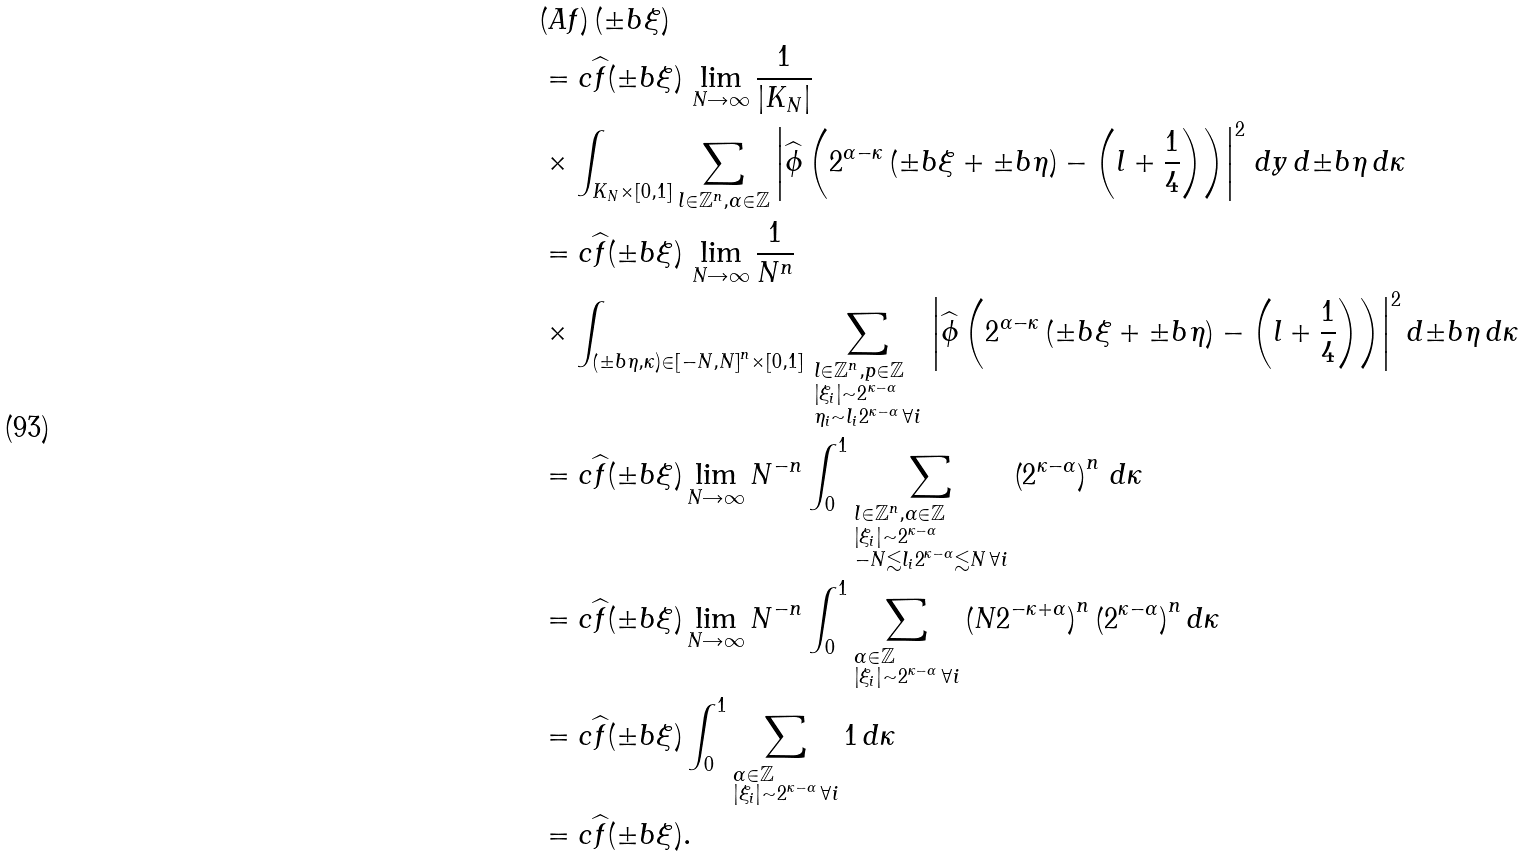Convert formula to latex. <formula><loc_0><loc_0><loc_500><loc_500>& ( A f ) \, ( { \pm b { \xi } } ) \\ & = c \widehat { f } ( { \pm b { \xi } } ) \, \lim _ { N \rightarrow \infty } \frac { 1 } { | K _ { N } | } \\ & \times \int _ { K _ { N } \times \left [ 0 , 1 \right ] } \sum _ { { l } \in \mathbb { Z } ^ { n } , \alpha \in \mathbb { Z } } \left | { \widehat { \phi } } \left ( 2 ^ { \alpha - \kappa } \left ( { \pm b { \xi } } + { \pm b { \eta } } \right ) - \left ( { l } + \frac { 1 } { 4 } \right ) \right ) \right | ^ { 2 } \, d { y } \, d { \pm b { \eta } } \, d \kappa \\ & = c \widehat { f } ( { \pm b { \xi } } ) \, \lim _ { N \rightarrow \infty } \frac { 1 } { N ^ { n } } \\ & \times \int _ { \left ( { \pm b { \eta } } , \kappa \right ) \in \left [ - N , N \right ] ^ { n } \times \left [ 0 , 1 \right ] } \, \sum _ { \begin{subarray} { c } { l } \in \mathbb { Z } ^ { n } , p \in \mathbb { Z } \\ \left | \xi _ { i } \right | \sim 2 ^ { \kappa - \alpha } \\ \eta _ { i } \sim l _ { i } 2 ^ { \kappa - \alpha } \, \forall i \end{subarray} } \, \left | { \widehat { \phi } } \left ( 2 ^ { \alpha - \kappa } \left ( { \pm b { \xi } } + { \pm b { \eta } } \right ) - \left ( { l } + \frac { 1 } { 4 } \right ) \right ) \right | ^ { 2 } d { \pm b { \eta } } \, d \kappa \\ & = c \widehat { f } ( { \pm b { \xi } } ) \lim _ { N \rightarrow \infty } N ^ { - n } \int _ { 0 } ^ { 1 } \sum _ { \begin{subarray} { c } { l } \in \mathbb { Z } ^ { n } , \alpha \in \mathbb { Z } \\ \left | \xi _ { i } \right | \sim 2 ^ { \kappa - \alpha } \\ - N \lesssim l _ { i } 2 ^ { \kappa - \alpha } \lesssim N \, \forall i \end{subarray} } \left ( 2 ^ { \kappa - \alpha } \right ) ^ { n } \, d \kappa \\ & = c \widehat { f } ( { \pm b { \xi } } ) \lim _ { N \rightarrow \infty } N ^ { - n } \int _ { 0 } ^ { 1 } \sum _ { \begin{subarray} { c } \alpha \in \mathbb { Z } \\ \left | \xi _ { i } \right | \sim 2 ^ { \kappa - \alpha } \, \forall i \end{subarray} } \left ( N 2 ^ { - \kappa + \alpha } \right ) ^ { n } \left ( 2 ^ { \kappa - \alpha } \right ) ^ { n } d \kappa \\ & = c \widehat { f } ( { \pm b { \xi } } ) \int _ { 0 } ^ { 1 } \sum _ { \begin{subarray} { c } \alpha \in \mathbb { Z } \\ \left | \xi _ { i } \right | \sim 2 ^ { \kappa - \alpha } \, \forall i \end{subarray} } 1 \, d \kappa \\ & = c \widehat { f } ( { \pm b { \xi } } ) .</formula> 